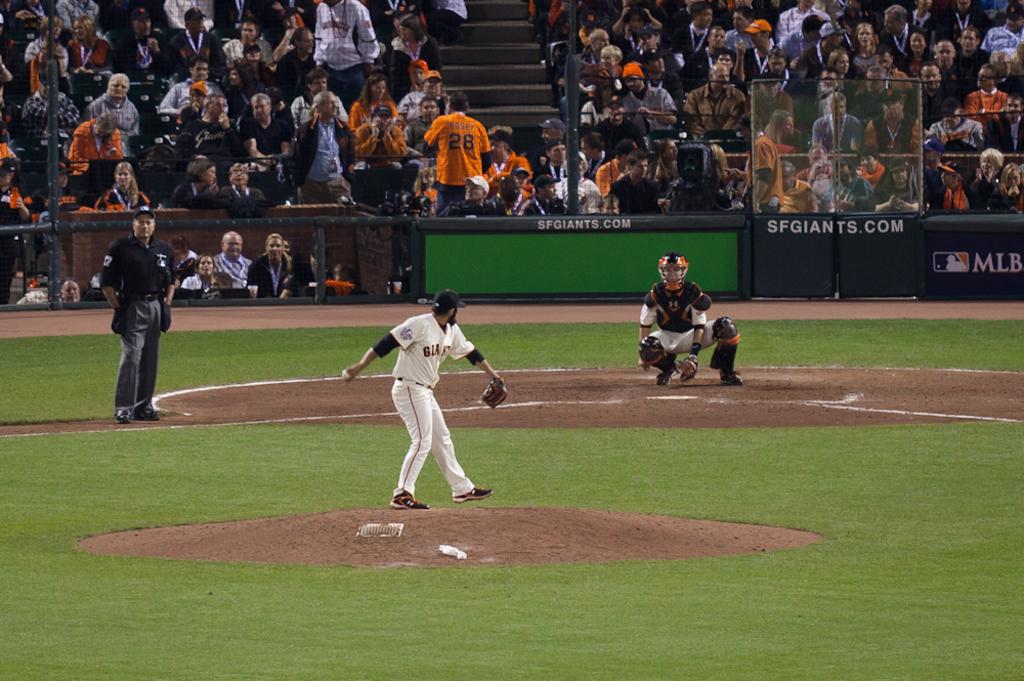<image>
Share a concise interpretation of the image provided. a pitcher throwing a ball while the backstop says sfgiants.com 